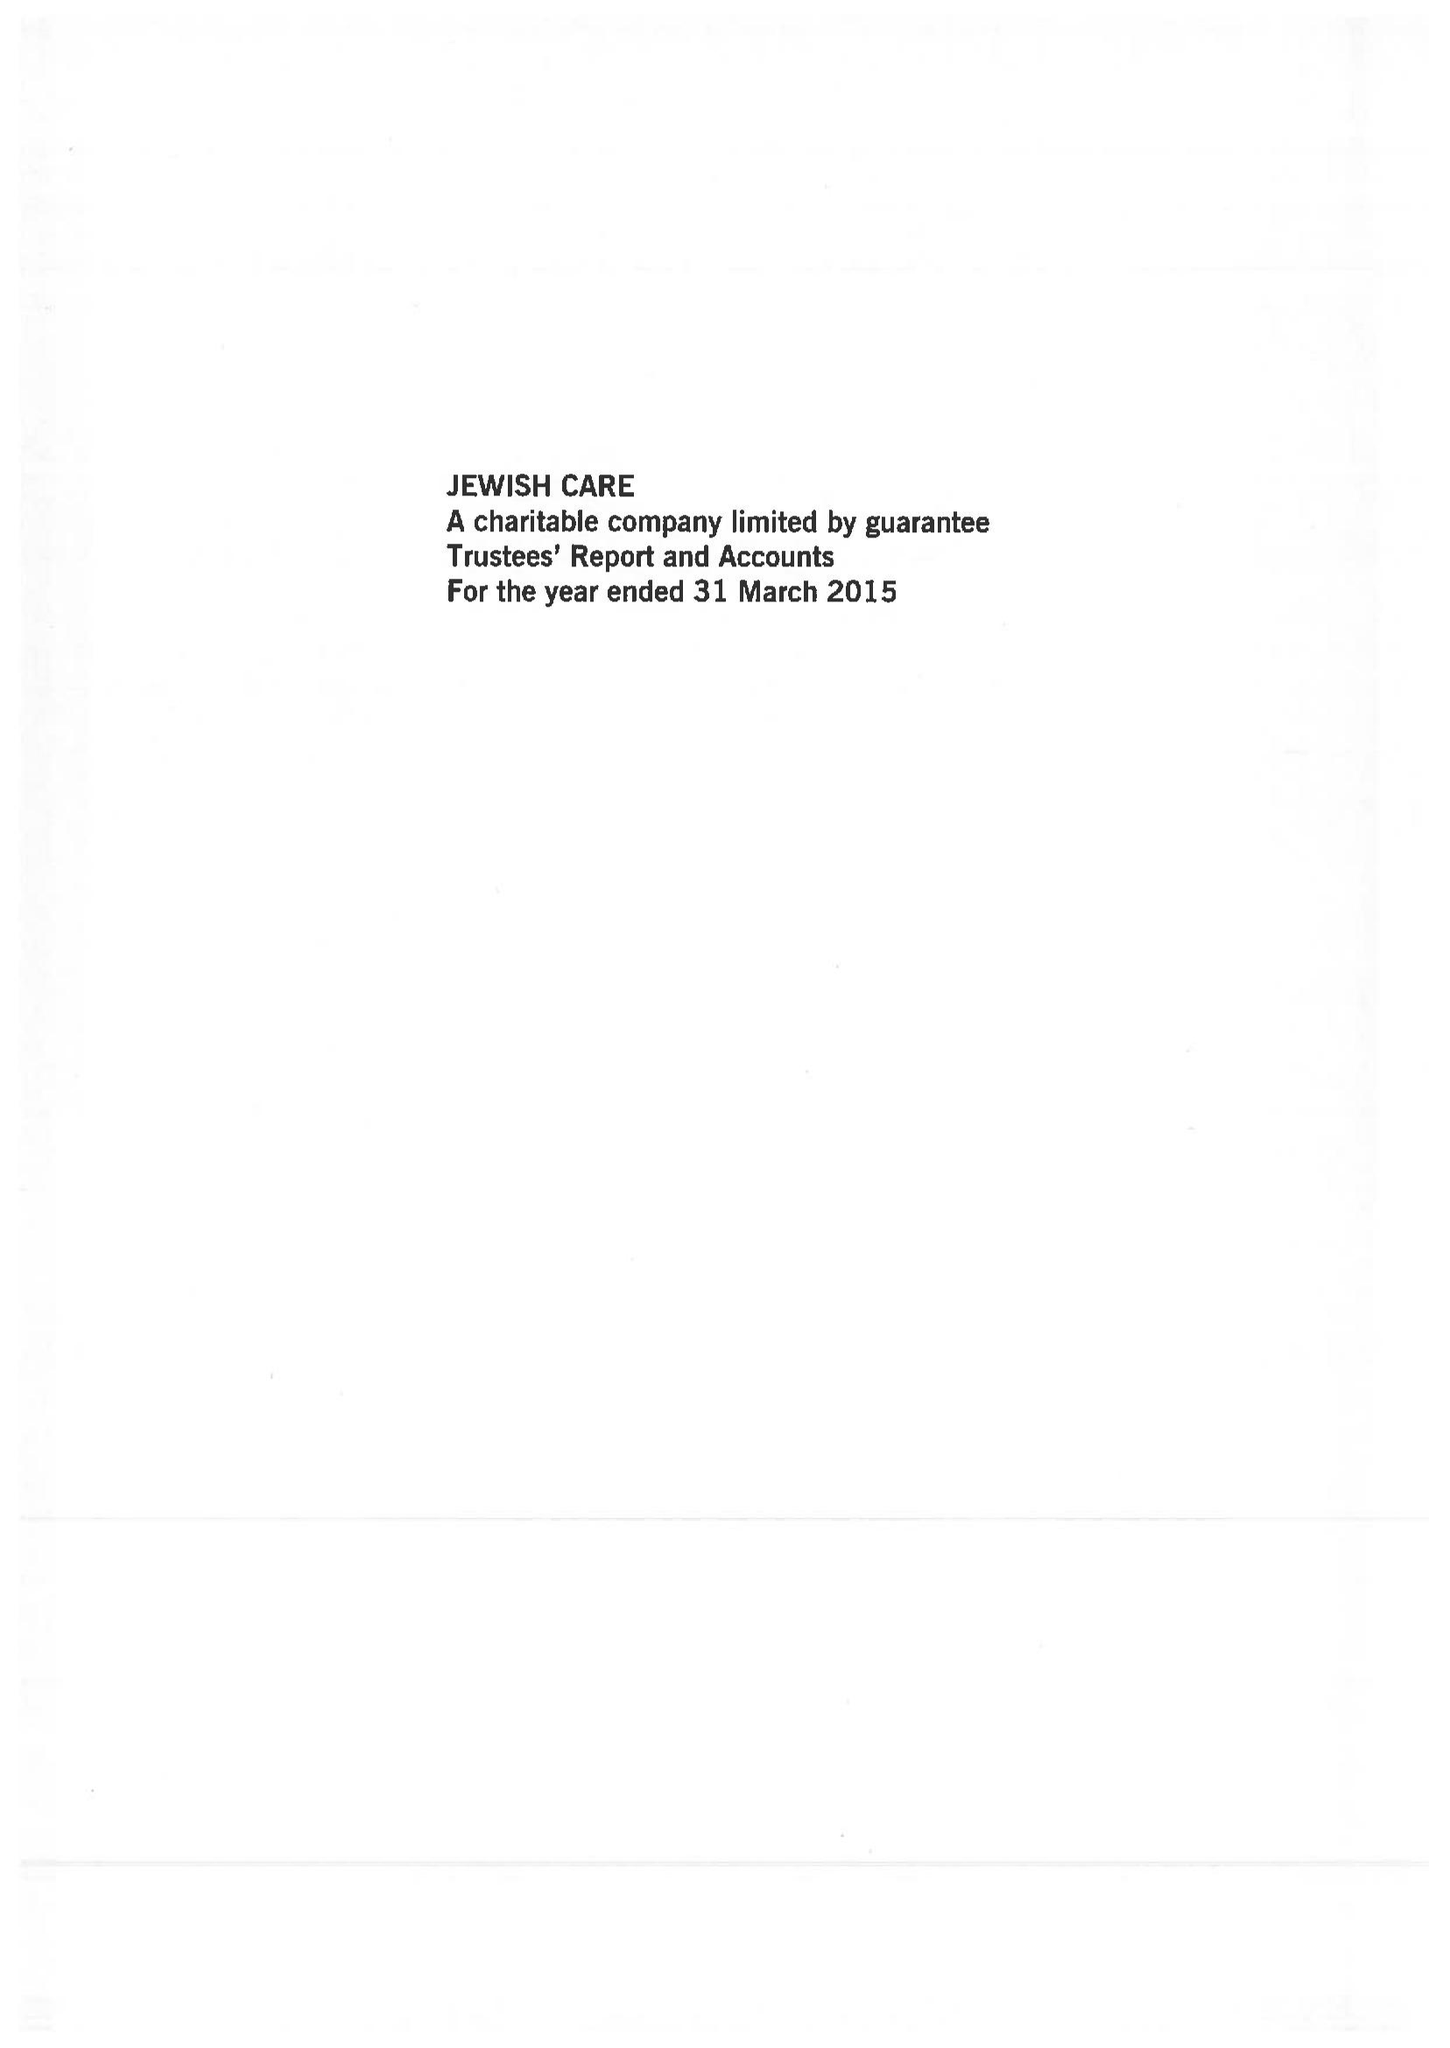What is the value for the address__post_town?
Answer the question using a single word or phrase. LONDON 